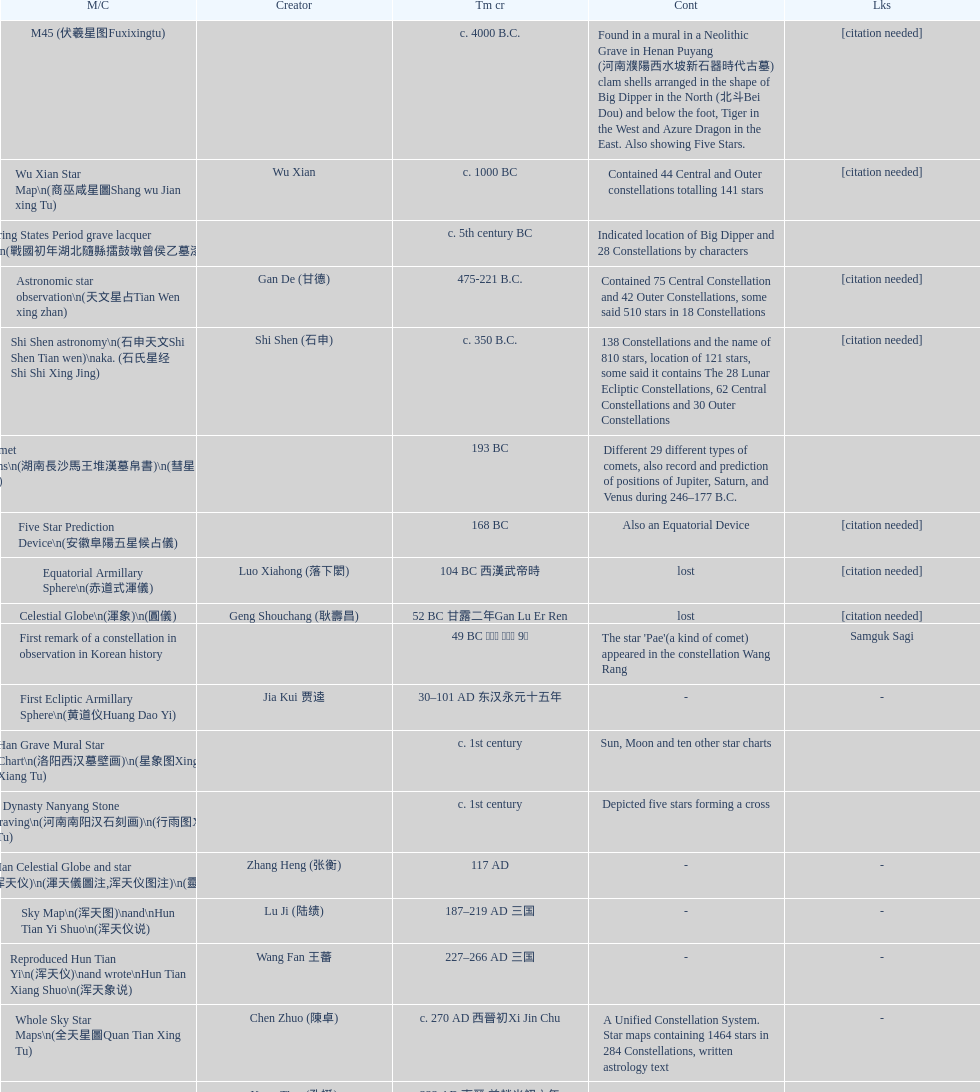What is the difference between the five star prediction device's date of creation and the han comet diagrams' date of creation? 25 years. 